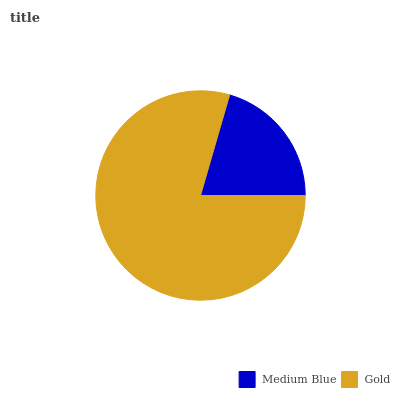Is Medium Blue the minimum?
Answer yes or no. Yes. Is Gold the maximum?
Answer yes or no. Yes. Is Gold the minimum?
Answer yes or no. No. Is Gold greater than Medium Blue?
Answer yes or no. Yes. Is Medium Blue less than Gold?
Answer yes or no. Yes. Is Medium Blue greater than Gold?
Answer yes or no. No. Is Gold less than Medium Blue?
Answer yes or no. No. Is Gold the high median?
Answer yes or no. Yes. Is Medium Blue the low median?
Answer yes or no. Yes. Is Medium Blue the high median?
Answer yes or no. No. Is Gold the low median?
Answer yes or no. No. 